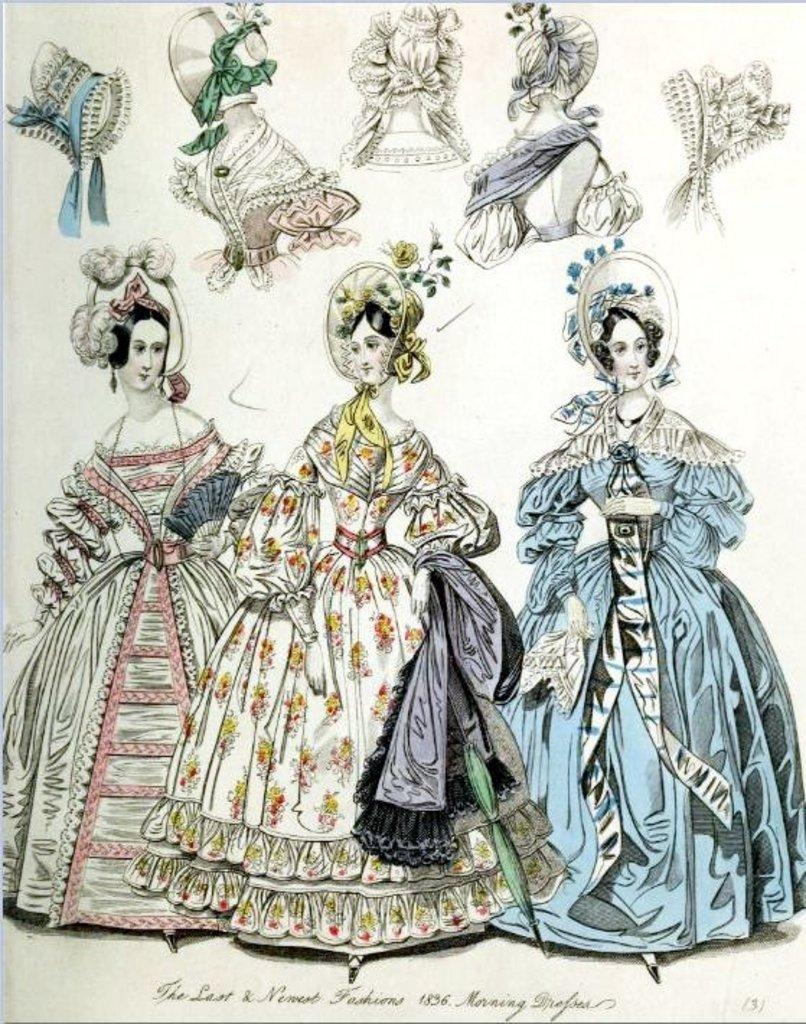What type of images are present in the picture? The image contains pictures of ladies. What else can be seen on the paper besides the images of ladies? There are accessories printed on the paper. Is there any text present in the image? Yes, there is text at the bottom of the image. Are there any plants visible in the image? There are no plants present in the image; it contains pictures of ladies and accessories printed on paper, along with text at the bottom. 